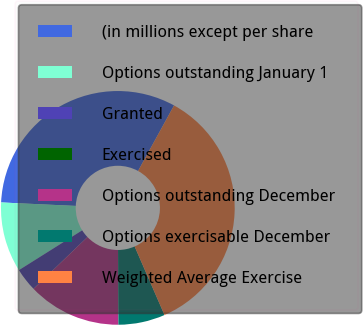Convert chart to OTSL. <chart><loc_0><loc_0><loc_500><loc_500><pie_chart><fcel>(in millions except per share<fcel>Options outstanding January 1<fcel>Granted<fcel>Exercised<fcel>Options outstanding December<fcel>Options exercisable December<fcel>Weighted Average Exercise<nl><fcel>32.25%<fcel>9.68%<fcel>3.23%<fcel>0.01%<fcel>12.9%<fcel>6.46%<fcel>35.47%<nl></chart> 